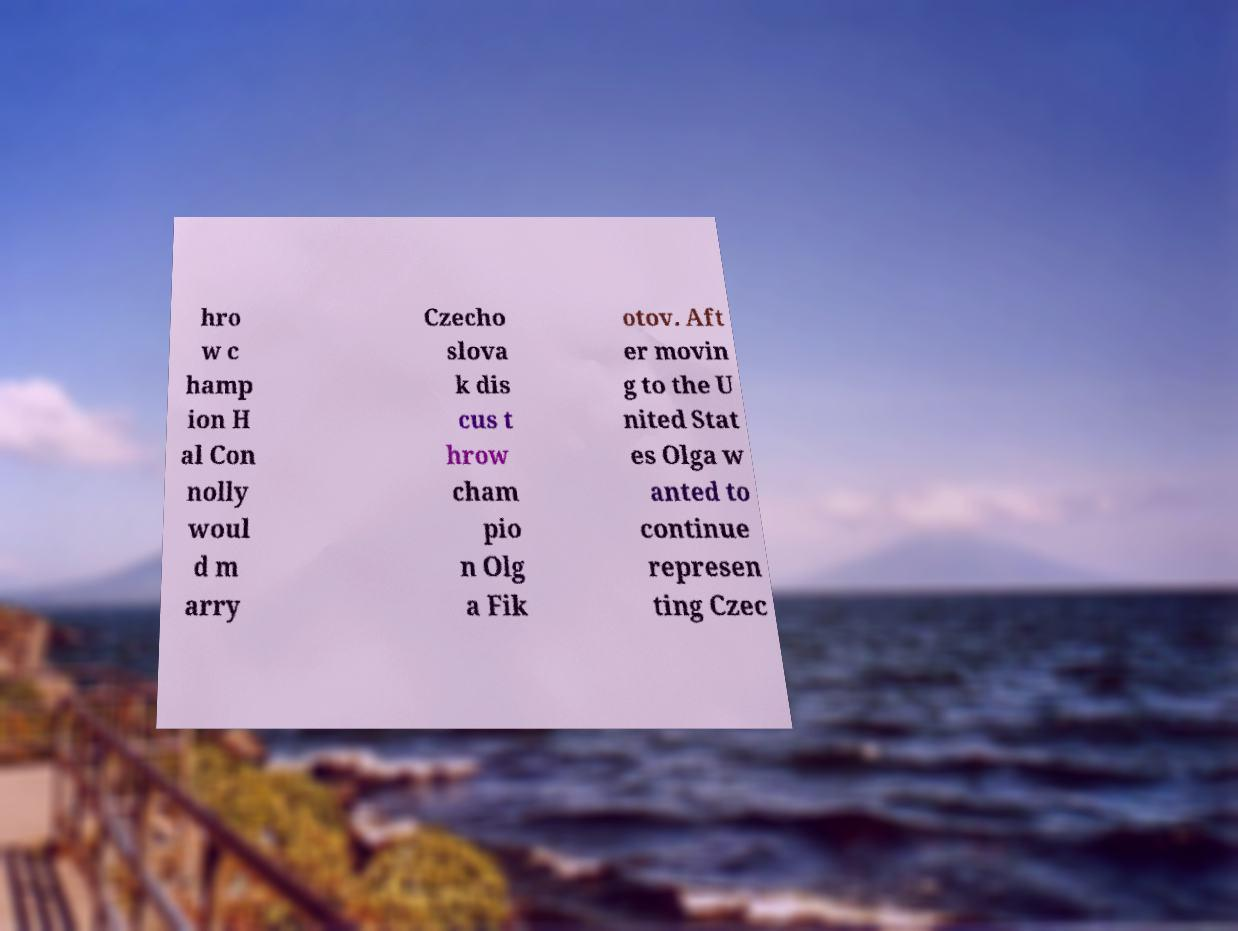Can you accurately transcribe the text from the provided image for me? hro w c hamp ion H al Con nolly woul d m arry Czecho slova k dis cus t hrow cham pio n Olg a Fik otov. Aft er movin g to the U nited Stat es Olga w anted to continue represen ting Czec 